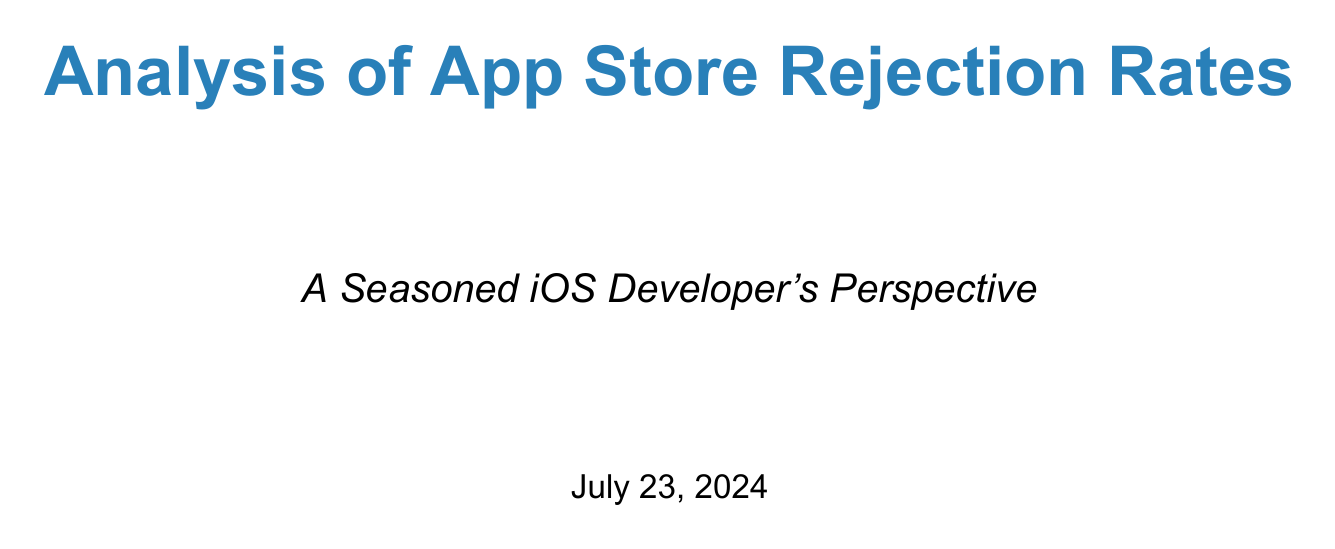what was the rejection rate in 2022? The document states that the rejection rate in 2022 was 36%.
Answer: 36% what percentage of rejections is due to Privacy and Security? The document lists that 28% of rejections are due to Privacy and Security.
Answer: 28% which iOS version saw an 8% increase in rejections? According to the document, iOS 16 saw an 8% increase in rejections related to privacy features.
Answer: iOS 16 how many hours did the developer spend refactoring code for privacy guidelines? The document mentions that the developer spent an additional 40 hours on this task.
Answer: 40 hours what is one strategy for success mentioned in the document? The document lists several strategies, including proactive testing on beta iOS versions.
Answer: Proactive testing on beta iOS versions what is the correlation of rejection reasons with iOS updates related to User Interface and Design? The document states that the correlation with iOS updates for this category is low.
Answer: Low how much did the development time increase for maintaining separate codebases? The document indicates that the development time increased by 25%.
Answer: 25% what is a developer challenge mentioned related to rapidly changing guidelines? The document specifies that keeping up with rapidly changing guidelines is a challenge faced by developers.
Answer: Keeping up with rapidly changing guidelines what significant impact do iOS updates have on rejection rates? iOS updates significantly impact rejection rates, particularly in privacy and security areas.
Answer: Privacy and security areas 